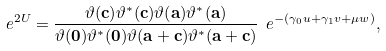Convert formula to latex. <formula><loc_0><loc_0><loc_500><loc_500>\ e ^ { 2 U } = \frac { \vartheta ( \mathbf c ) \vartheta ^ { * } ( \mathbf c ) \vartheta ( \mathbf a ) \vartheta ^ { * } ( \mathbf a ) } { \vartheta ( \mathbf 0 ) \vartheta ^ { * } ( \mathbf 0 ) \vartheta ( \mathbf a + \mathbf c ) \vartheta ^ { * } ( \mathbf a + \mathbf c ) } \ e ^ { - ( \gamma _ { 0 } u + \gamma _ { 1 } v + \mu w ) } ,</formula> 